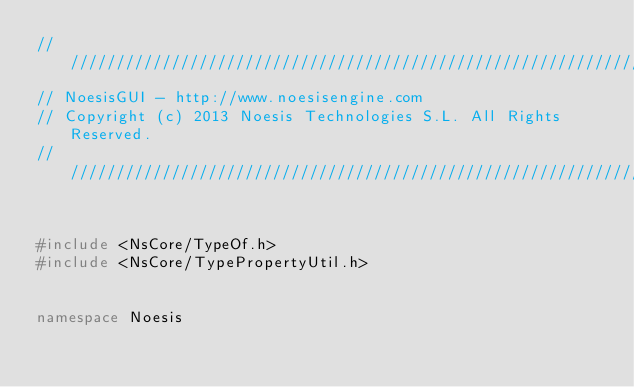Convert code to text. <code><loc_0><loc_0><loc_500><loc_500><_C++_>////////////////////////////////////////////////////////////////////////////////////////////////////
// NoesisGUI - http://www.noesisengine.com
// Copyright (c) 2013 Noesis Technologies S.L. All Rights Reserved.
////////////////////////////////////////////////////////////////////////////////////////////////////


#include <NsCore/TypeOf.h>
#include <NsCore/TypePropertyUtil.h>


namespace Noesis</code> 